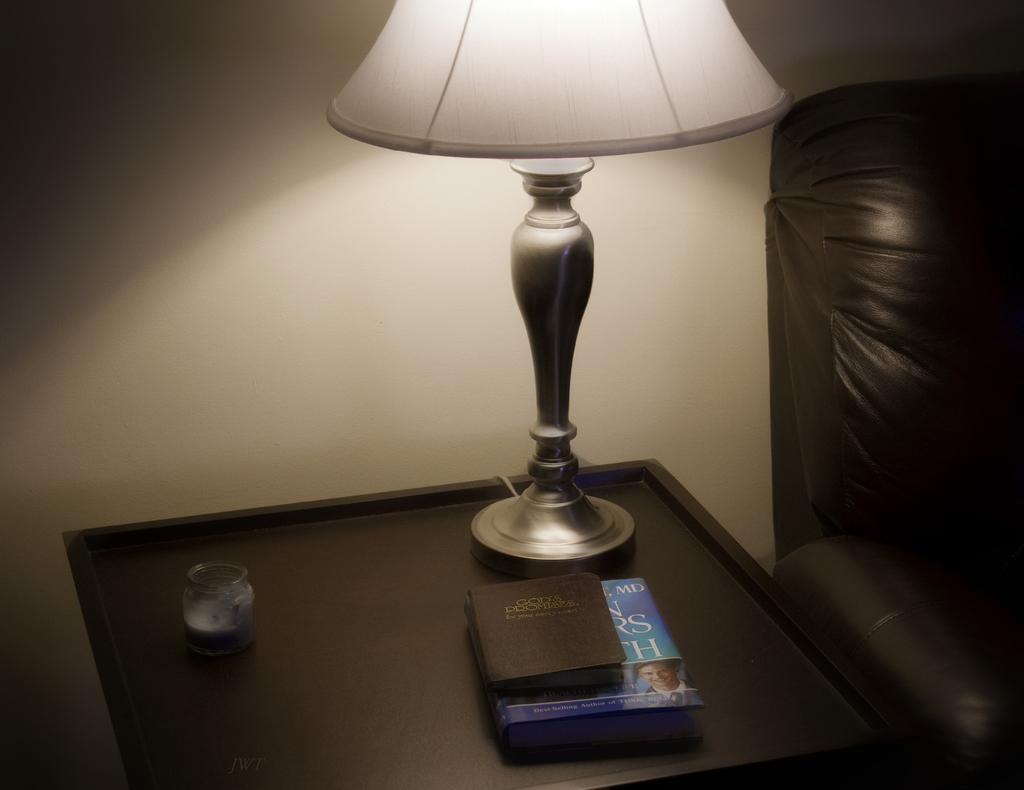Please provide a concise description of this image. On this table there are books, lantern-lamp and jar. Beside this table there is a couch. 